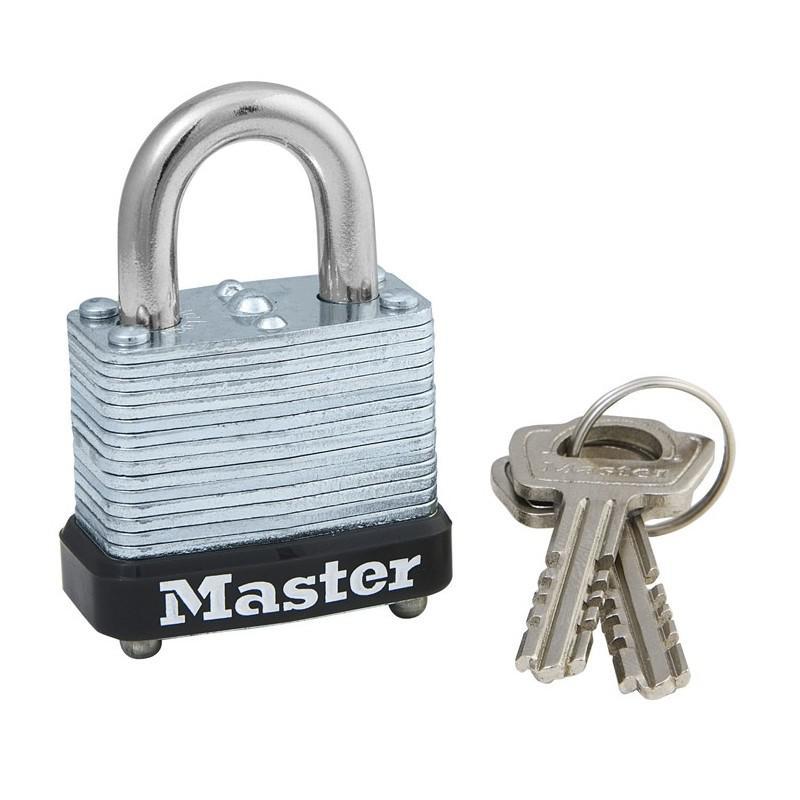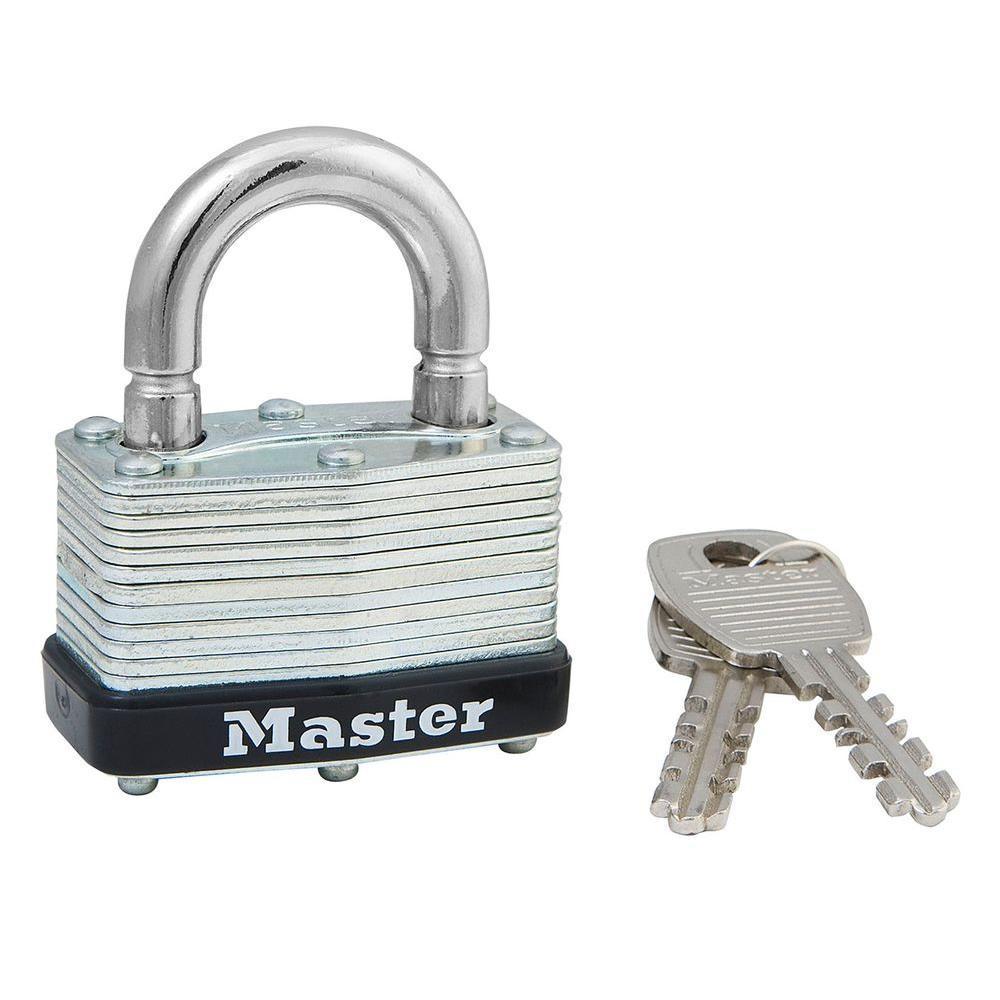The first image is the image on the left, the second image is the image on the right. Assess this claim about the two images: "Each image shows a red padlock, and in one image there is also one or more keys visible". Correct or not? Answer yes or no. No. The first image is the image on the left, the second image is the image on the right. Analyze the images presented: Is the assertion "Each image includes just one lock, and all locks have red bodies." valid? Answer yes or no. No. 